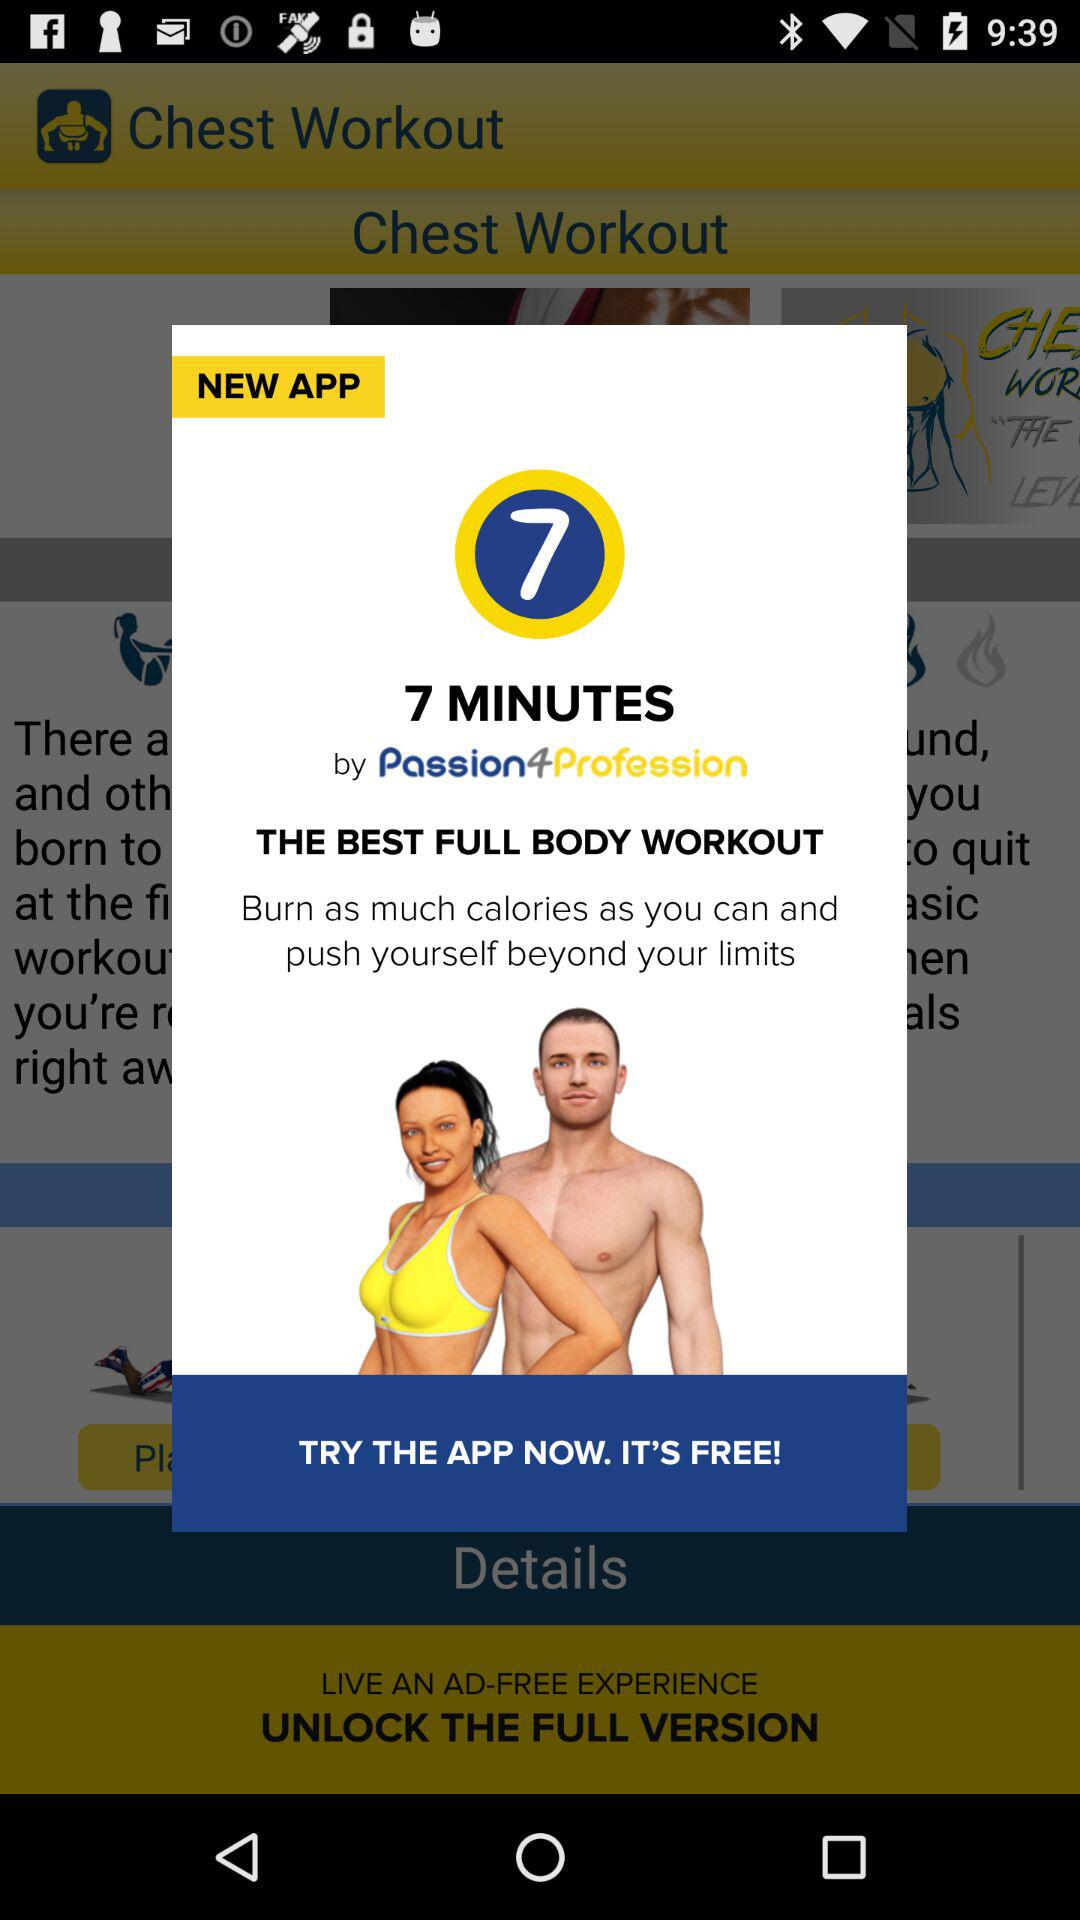Who is the founder of the "7 MINUTES" app? The founder of the app is "Passion4Profession". 